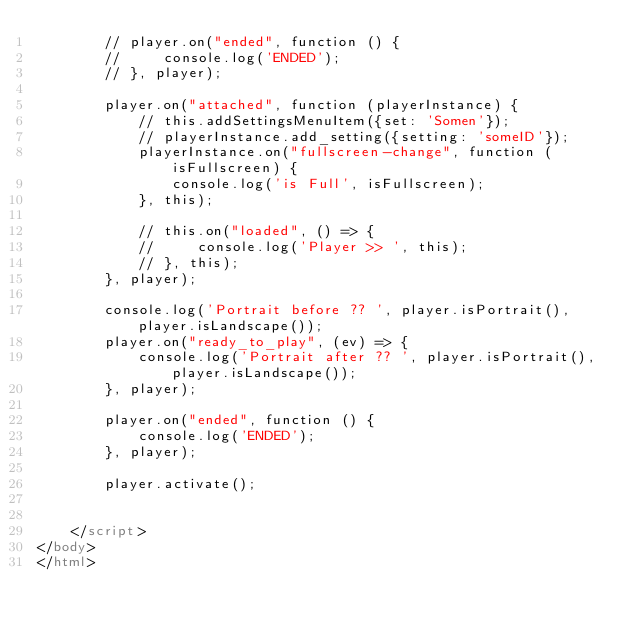Convert code to text. <code><loc_0><loc_0><loc_500><loc_500><_HTML_>        // player.on("ended", function () {
        //     console.log('ENDED');
        // }, player);

        player.on("attached", function (playerInstance) {
            // this.addSettingsMenuItem({set: 'Somen'});
            // playerInstance.add_setting({setting: 'someID'});
            playerInstance.on("fullscreen-change", function (isFullscreen) {
                console.log('is Full', isFullscreen);
            }, this);

            // this.on("loaded", () => {
            //     console.log('Player >> ', this);
            // }, this);
        }, player);

        console.log('Portrait before ?? ', player.isPortrait(), player.isLandscape());
        player.on("ready_to_play", (ev) => {
            console.log('Portrait after ?? ', player.isPortrait(), player.isLandscape());
        }, player);

        player.on("ended", function () {
            console.log('ENDED');
        }, player);

        player.activate();


    </script>
</body>
</html>
</code> 